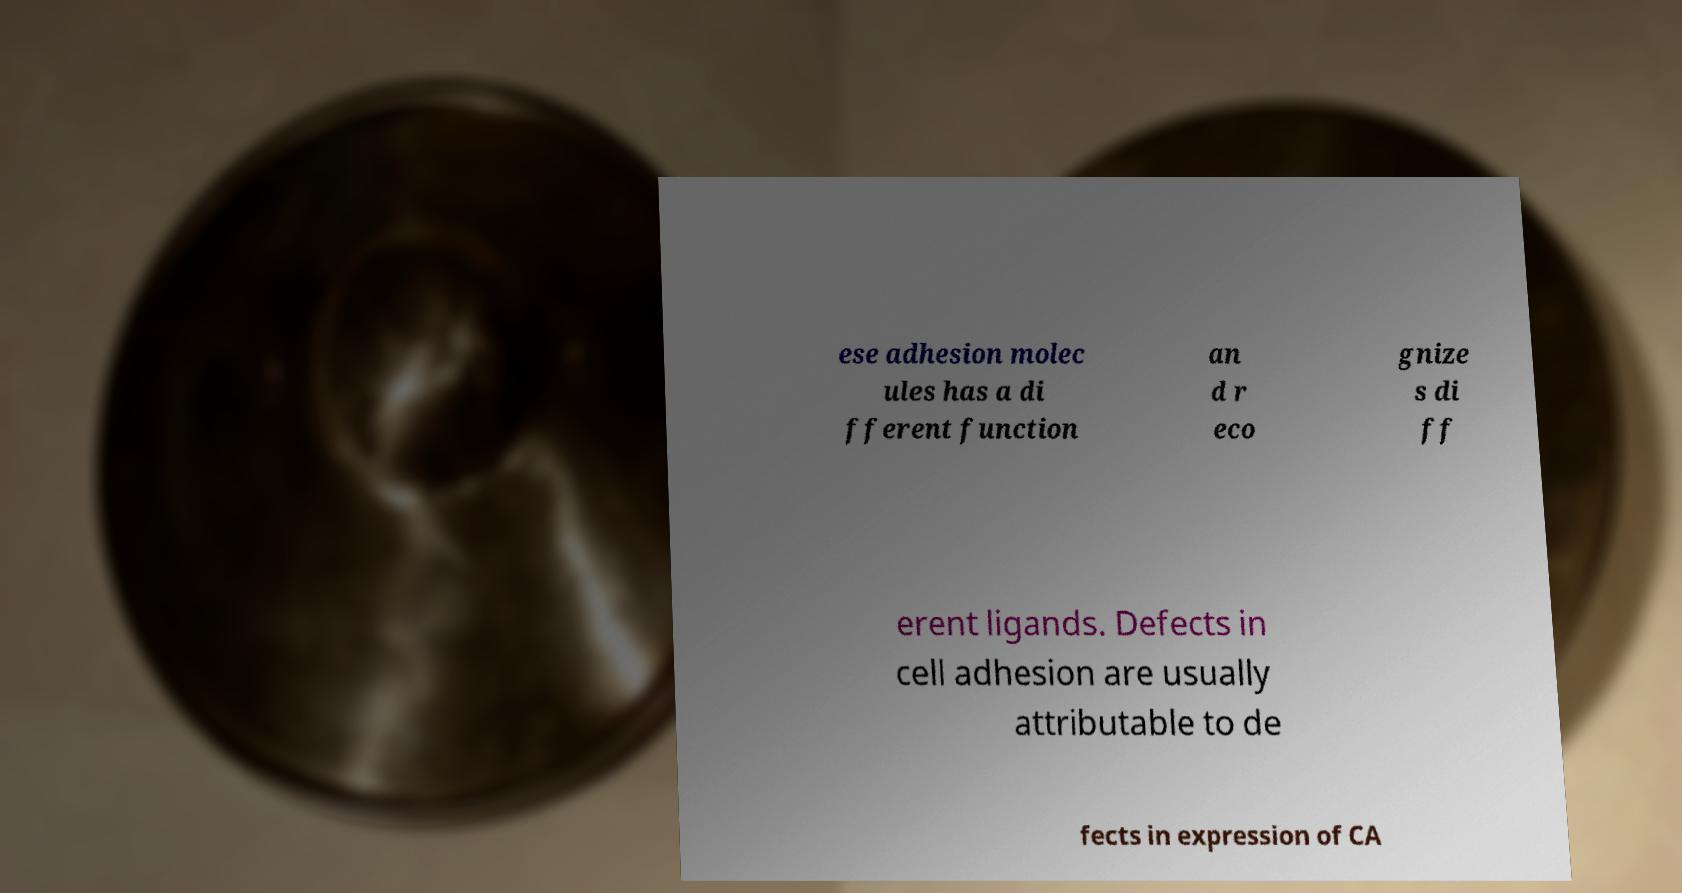Please read and relay the text visible in this image. What does it say? ese adhesion molec ules has a di fferent function an d r eco gnize s di ff erent ligands. Defects in cell adhesion are usually attributable to de fects in expression of CA 